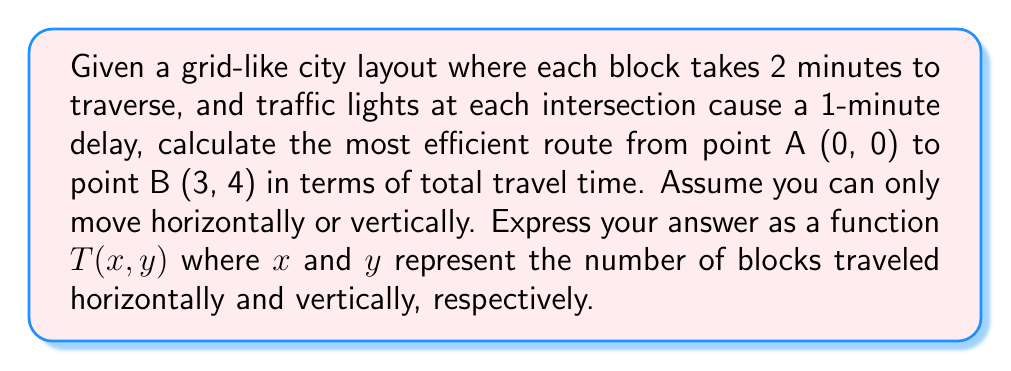Give your solution to this math problem. Let's approach this step-by-step:

1) First, we need to understand what contributes to the total travel time:
   - Time to traverse blocks
   - Time spent waiting at traffic lights

2) Let $x$ be the number of horizontal blocks and $y$ be the number of vertical blocks.

3) Time to traverse blocks:
   - Each block takes 2 minutes
   - Total blocks traveled = $x + y$
   - Time for blocks = $2(x + y)$ minutes

4) Time spent at traffic lights:
   - Number of intersections crossed = $x + y$
   - Each intersection causes a 1-minute delay
   - Time for lights = $x + y$ minutes

5) Total travel time function:
   $$T(x, y) = 2(x + y) + (x + y) = 3(x + y)$$

6) For the most efficient route from (0, 0) to (3, 4):
   - We need to travel 3 blocks horizontally and 4 blocks vertically
   - The order doesn't matter due to the grid layout

7) Plugging in $x = 3$ and $y = 4$ into our function:
   $$T(3, 4) = 3(3 + 4) = 3(7) = 21$$

Therefore, the most efficient route will take 21 minutes.
Answer: $T(x, y) = 3(x + y)$ 